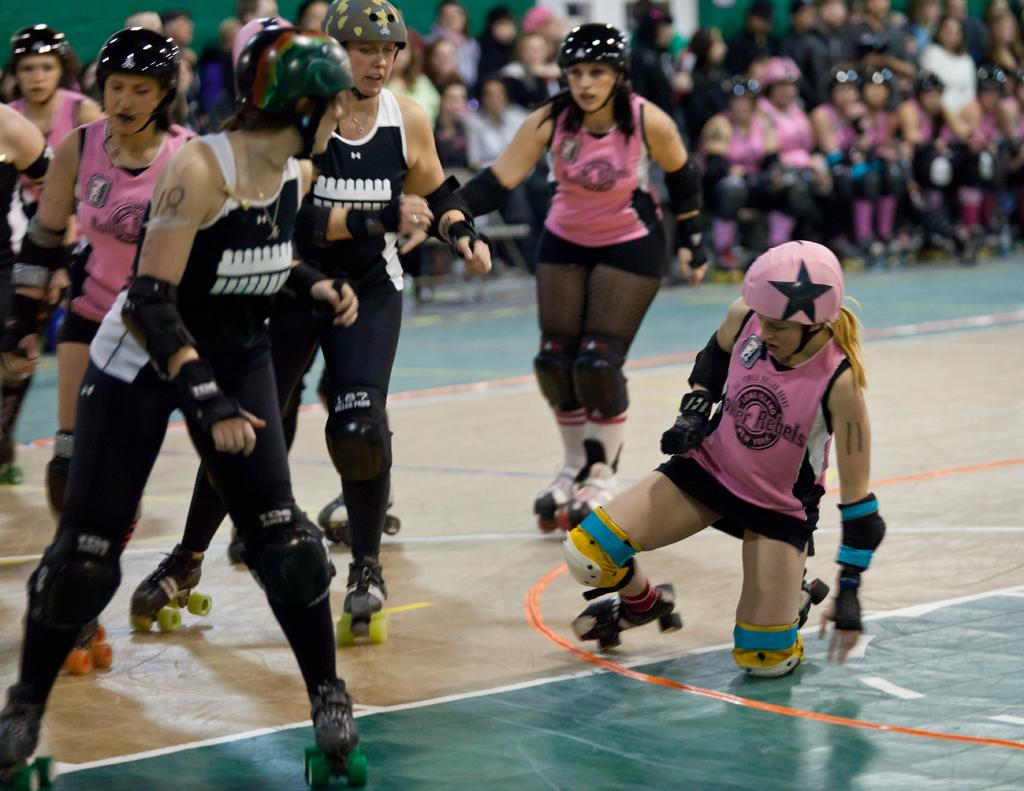What is happening in the background of the image? There are people in the background of the image. What are the people wearing on their heads? The people are wearing helmets. What activity are the people engaged in? The people are skating on the floor. What type of cabbage can be seen growing on the floor in the image? There is no cabbage present in the image; the people are skating on the floor. 